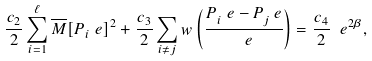Convert formula to latex. <formula><loc_0><loc_0><loc_500><loc_500>\frac { c _ { 2 } } { 2 } \sum _ { i = 1 } ^ { \ell } \overline { M } [ P _ { i } ^ { \ } e ] ^ { 2 } + \frac { c _ { 3 } } { 2 } \sum _ { i \neq j } w \left ( \frac { P _ { i } ^ { \ } e - P _ { j } ^ { \ } e } { \ e } \right ) = \frac { c _ { 4 } } { 2 } \ e ^ { 2 \beta } ,</formula> 